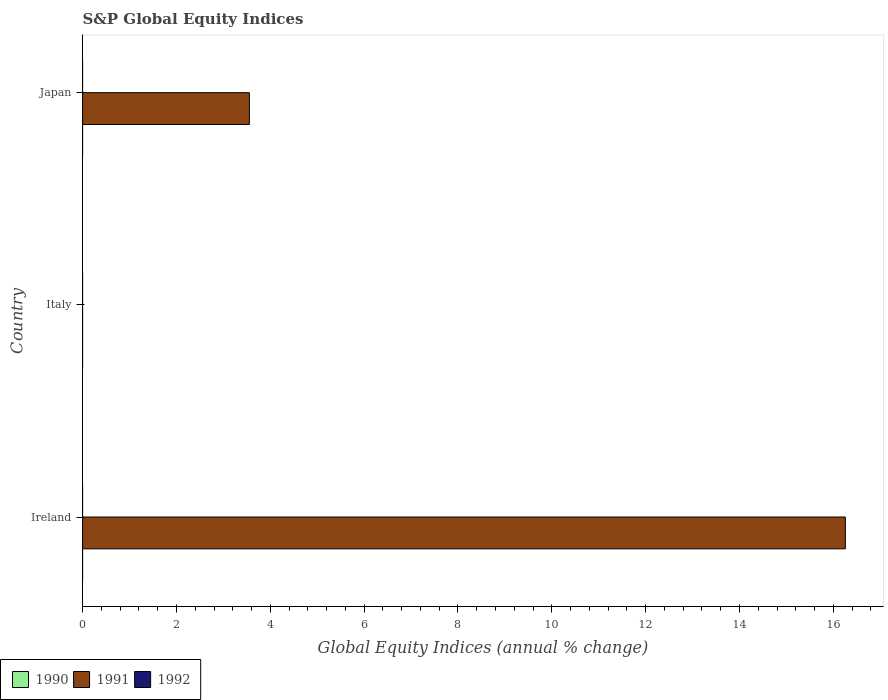Are the number of bars per tick equal to the number of legend labels?
Offer a terse response. No. Are the number of bars on each tick of the Y-axis equal?
Your response must be concise. No. How many bars are there on the 3rd tick from the bottom?
Keep it short and to the point. 1. Across all countries, what is the maximum global equity indices in 1991?
Keep it short and to the point. 16.26. In which country was the global equity indices in 1991 maximum?
Your answer should be very brief. Ireland. What is the difference between the global equity indices in 1991 in Ireland and that in Japan?
Your response must be concise. 12.7. What is the difference between the global equity indices in 1992 in Italy and the global equity indices in 1991 in Japan?
Your answer should be compact. -3.55. In how many countries, is the global equity indices in 1991 greater than 8 %?
Offer a terse response. 1. What is the difference between the highest and the lowest global equity indices in 1991?
Give a very brief answer. 16.26. In how many countries, is the global equity indices in 1990 greater than the average global equity indices in 1990 taken over all countries?
Offer a terse response. 0. Is it the case that in every country, the sum of the global equity indices in 1991 and global equity indices in 1992 is greater than the global equity indices in 1990?
Your answer should be very brief. No. Are all the bars in the graph horizontal?
Offer a terse response. Yes. How many countries are there in the graph?
Ensure brevity in your answer.  3. Does the graph contain any zero values?
Make the answer very short. Yes. Does the graph contain grids?
Keep it short and to the point. No. What is the title of the graph?
Your response must be concise. S&P Global Equity Indices. Does "1986" appear as one of the legend labels in the graph?
Keep it short and to the point. No. What is the label or title of the X-axis?
Provide a short and direct response. Global Equity Indices (annual % change). What is the Global Equity Indices (annual % change) of 1991 in Ireland?
Give a very brief answer. 16.26. What is the Global Equity Indices (annual % change) in 1992 in Ireland?
Offer a terse response. 0. What is the Global Equity Indices (annual % change) in 1990 in Italy?
Ensure brevity in your answer.  0. What is the Global Equity Indices (annual % change) of 1991 in Italy?
Provide a short and direct response. 0. What is the Global Equity Indices (annual % change) of 1991 in Japan?
Give a very brief answer. 3.55. Across all countries, what is the maximum Global Equity Indices (annual % change) in 1991?
Your answer should be very brief. 16.26. Across all countries, what is the minimum Global Equity Indices (annual % change) of 1991?
Your response must be concise. 0. What is the total Global Equity Indices (annual % change) of 1990 in the graph?
Give a very brief answer. 0. What is the total Global Equity Indices (annual % change) of 1991 in the graph?
Offer a terse response. 19.81. What is the difference between the Global Equity Indices (annual % change) of 1991 in Ireland and that in Japan?
Provide a short and direct response. 12.7. What is the average Global Equity Indices (annual % change) of 1990 per country?
Offer a very short reply. 0. What is the average Global Equity Indices (annual % change) of 1991 per country?
Provide a succinct answer. 6.6. What is the ratio of the Global Equity Indices (annual % change) in 1991 in Ireland to that in Japan?
Give a very brief answer. 4.57. What is the difference between the highest and the lowest Global Equity Indices (annual % change) of 1991?
Your answer should be compact. 16.26. 